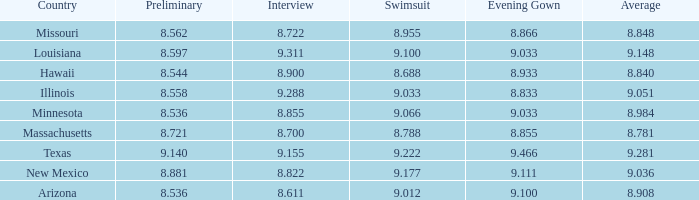I'm looking to parse the entire table for insights. Could you assist me with that? {'header': ['Country', 'Preliminary', 'Interview', 'Swimsuit', 'Evening Gown', 'Average'], 'rows': [['Missouri', '8.562', '8.722', '8.955', '8.866', '8.848'], ['Louisiana', '8.597', '9.311', '9.100', '9.033', '9.148'], ['Hawaii', '8.544', '8.900', '8.688', '8.933', '8.840'], ['Illinois', '8.558', '9.288', '9.033', '8.833', '9.051'], ['Minnesota', '8.536', '8.855', '9.066', '9.033', '8.984'], ['Massachusetts', '8.721', '8.700', '8.788', '8.855', '8.781'], ['Texas', '9.140', '9.155', '9.222', '9.466', '9.281'], ['New Mexico', '8.881', '8.822', '9.177', '9.111', '9.036'], ['Arizona', '8.536', '8.611', '9.012', '9.100', '8.908']]} What was the average score for the country with the evening gown score of 9.100? 1.0. 